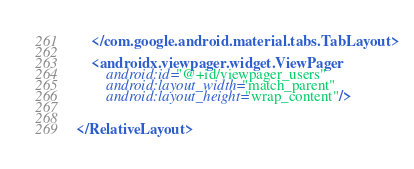Convert code to text. <code><loc_0><loc_0><loc_500><loc_500><_XML_>

    </com.google.android.material.tabs.TabLayout>

    <androidx.viewpager.widget.ViewPager
        android:id="@+id/viewpager_users"
        android:layout_width="match_parent"
        android:layout_height="wrap_content"/>


</RelativeLayout></code> 